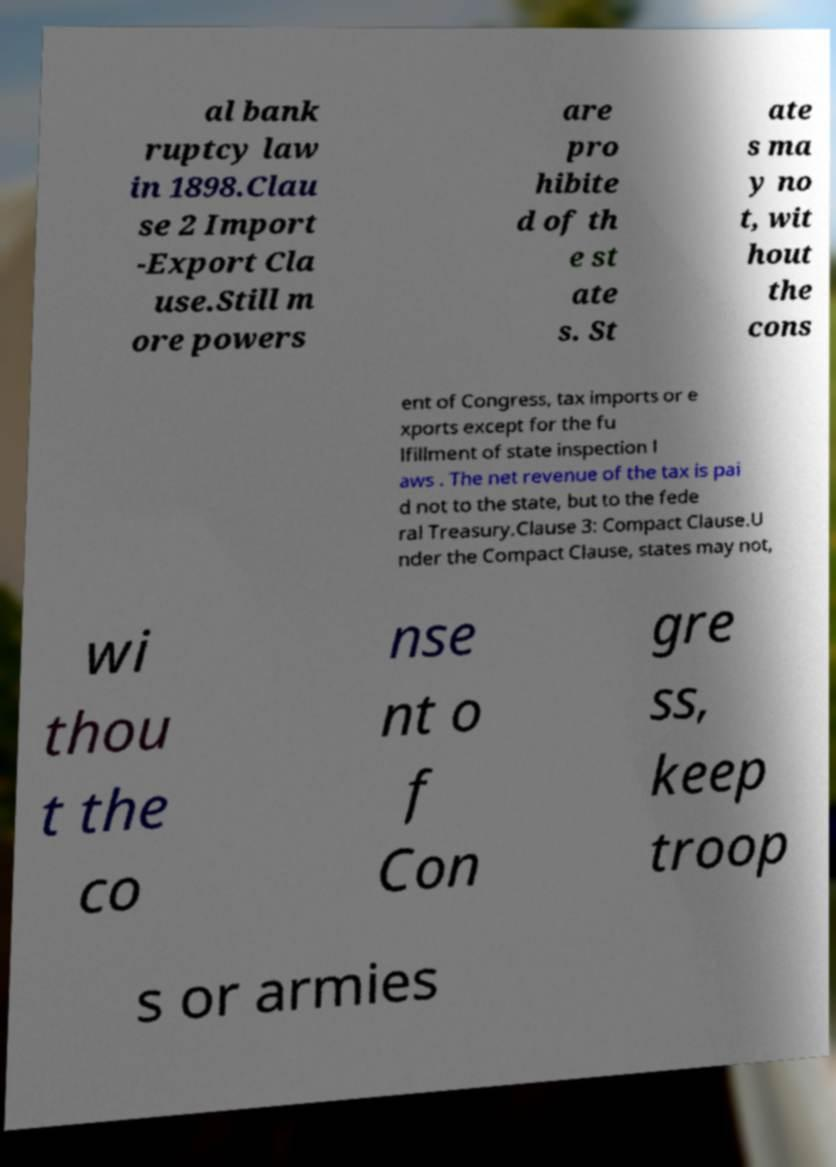I need the written content from this picture converted into text. Can you do that? al bank ruptcy law in 1898.Clau se 2 Import -Export Cla use.Still m ore powers are pro hibite d of th e st ate s. St ate s ma y no t, wit hout the cons ent of Congress, tax imports or e xports except for the fu lfillment of state inspection l aws . The net revenue of the tax is pai d not to the state, but to the fede ral Treasury.Clause 3: Compact Clause.U nder the Compact Clause, states may not, wi thou t the co nse nt o f Con gre ss, keep troop s or armies 